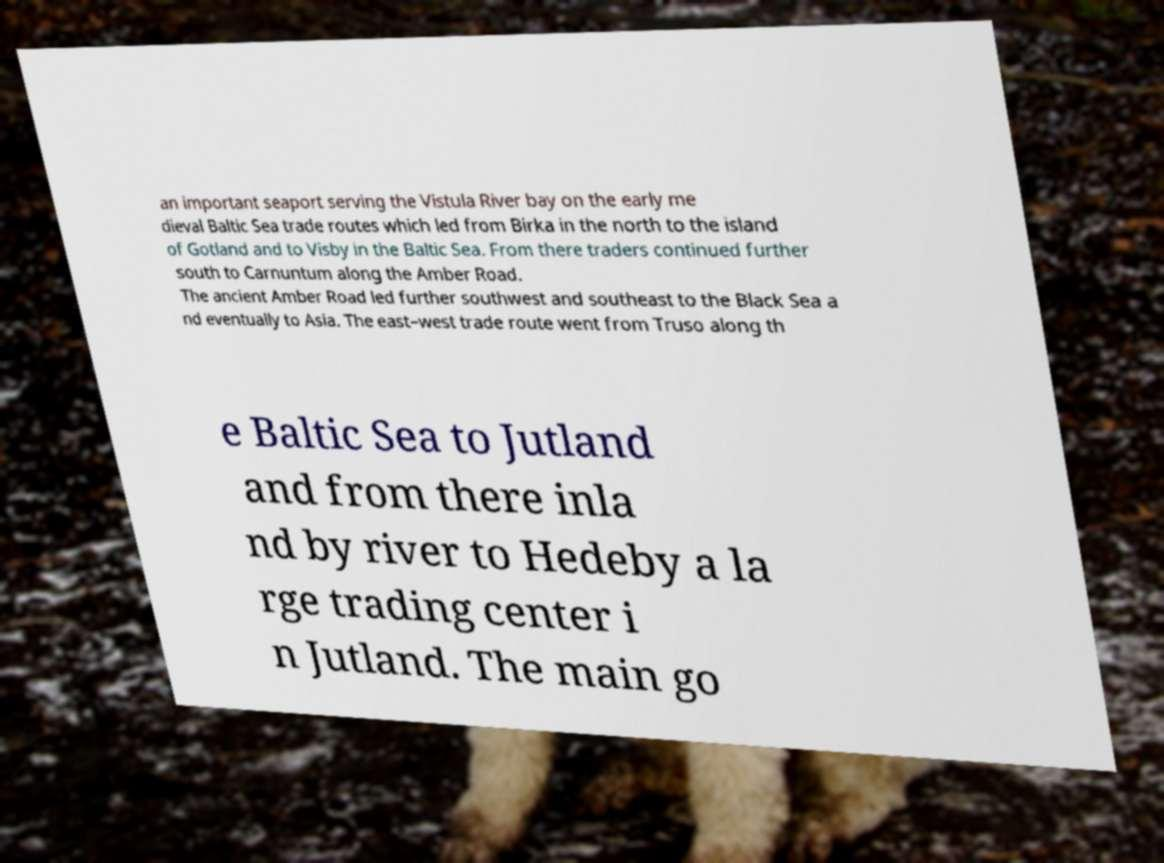I need the written content from this picture converted into text. Can you do that? an important seaport serving the Vistula River bay on the early me dieval Baltic Sea trade routes which led from Birka in the north to the island of Gotland and to Visby in the Baltic Sea. From there traders continued further south to Carnuntum along the Amber Road. The ancient Amber Road led further southwest and southeast to the Black Sea a nd eventually to Asia. The east–west trade route went from Truso along th e Baltic Sea to Jutland and from there inla nd by river to Hedeby a la rge trading center i n Jutland. The main go 